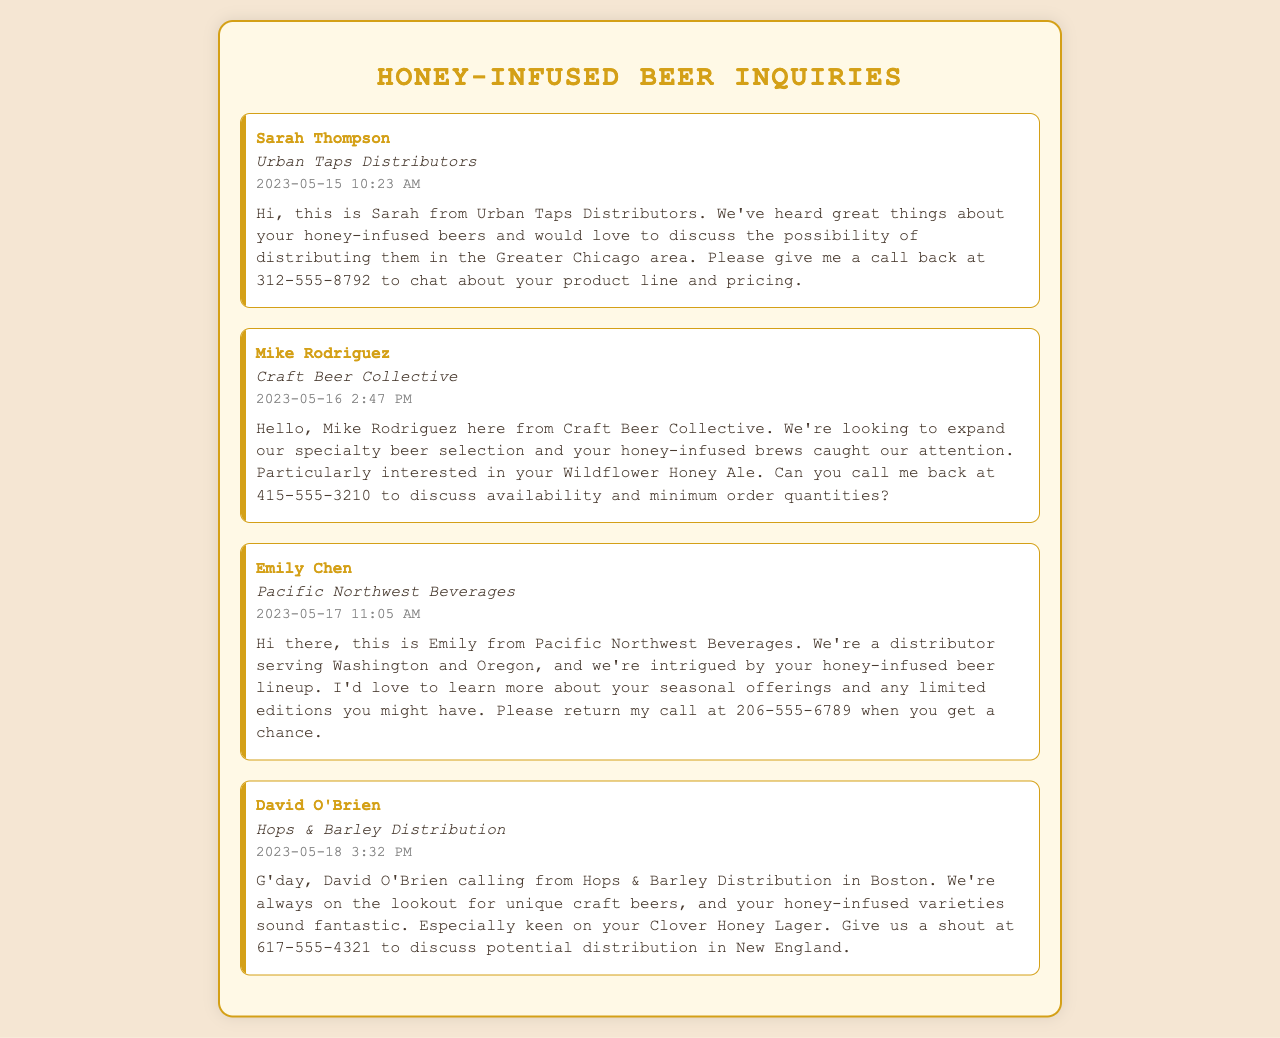What is the name of the first caller? The first caller in the document is Sarah Thompson from Urban Taps Distributors.
Answer: Sarah Thompson What company is Mike Rodriguez associated with? Mike Rodriguez is from Craft Beer Collective, as indicated in the voicemail.
Answer: Craft Beer Collective What is the timestamp of the voicemail from David O'Brien? The timestamp indicates when David O'Brien called, which is 2023-05-18 3:32 PM.
Answer: 2023-05-18 3:32 PM Which honey-infused beer is Emily Chen interested in? Emily Chen expresses interest in learning more about the seasonal offerings of the honey-infused beers, but does not specify a particular beer.
Answer: Seasonal offerings How many distributors have called regarding honey-infused beers? There are four distinct distributors who have left voicemails about honey-infused beers in the document.
Answer: Four What area does Urban Taps Distributors serve? Urban Taps Distributors is looking to distribute in the Greater Chicago area, as mentioned in the voicemail.
Answer: Greater Chicago area What is the phone number for Mike Rodriguez? Mike Rodriguez provides his callback number for potential discussions regarding distribution.
Answer: 415-555-3210 Which honey-infused variety is David O'Brien particularly keen on? David O'Brien specifically mentions being keen on the Clover Honey Lager in his voicemail.
Answer: Clover Honey Lager 